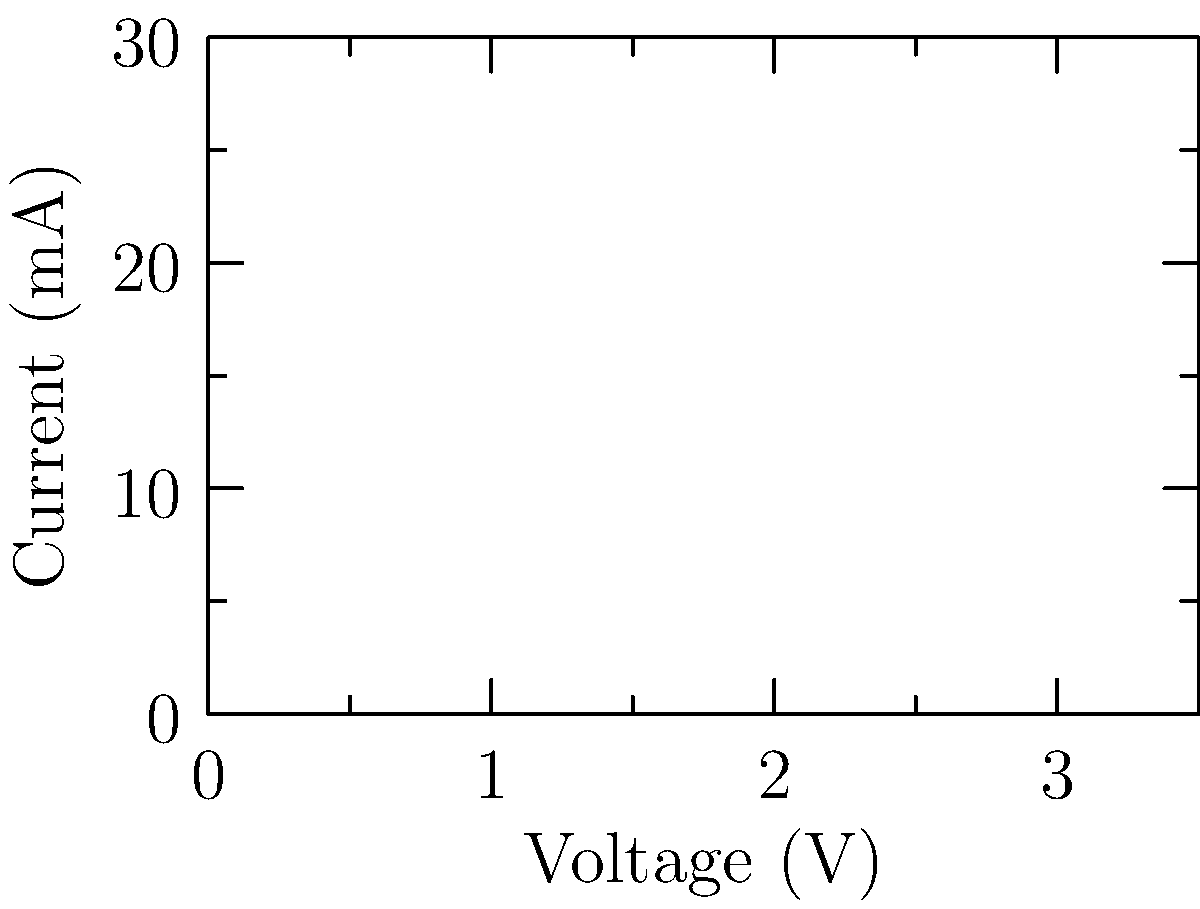In cinematography lighting, different colored LEDs are used to create various moods and atmospheres. The graph shows the voltage-current characteristics of four LED colors commonly used in film lighting. Which color LED would require the highest voltage to achieve a current of 20 mA, and how might this impact your lighting design for a scene blending Eastern and Western cultural elements? To answer this question, we need to analyze the voltage-current characteristics of the four LED colors shown in the graph. Let's break it down step-by-step:

1. Observe the curves: The graph shows four curves representing Red, Green, Blue, and Amber LEDs.

2. Identify the target current: We need to find which LED requires the highest voltage at 20 mA.

3. Analyze the curves at 20 mA:
   - Red LED: Requires approximately 1.8 V
   - Green LED: Requires approximately 2.2 V
   - Blue LED: Requires approximately 2.5 V
   - Amber LED: Requires approximately 2.8 V

4. Determine the highest voltage: The Amber LED requires the highest voltage (approximately 2.8 V) to achieve 20 mA.

5. Impact on lighting design:
   - Higher voltage requirement means more power consumption for Amber LEDs.
   - Amber light can create a warm, golden glow often associated with traditional Eastern lighting.
   - Combining Amber with cooler Blue or Green LEDs can create a contrast between warm and cool tones, symbolizing the fusion of Eastern and Western elements.
   - The higher power requirement of Amber LEDs might limit their use in battery-powered or mobile lighting setups, potentially affecting on-location shooting.
   - Careful balancing of Amber with other colors will be necessary to achieve the desired cultural blend without overwhelming the scene with warmth.

By understanding these characteristics, a director can make informed decisions about lighting design to effectively blend cultural elements while considering practical constraints of LED performance.
Answer: Amber LED; requires highest voltage (2.8V) at 20mA; enables warm Eastern tones, contrasts with cooler Western lighting, but demands more power. 